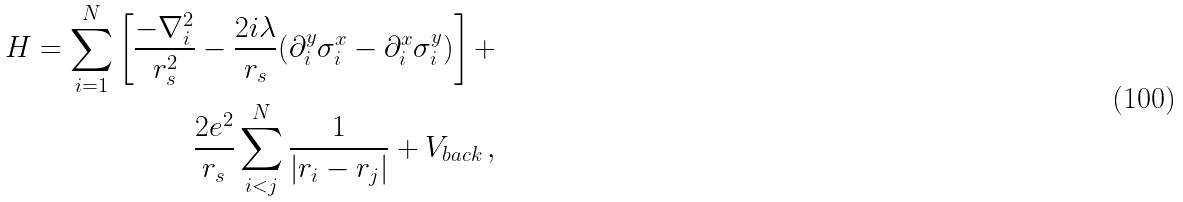<formula> <loc_0><loc_0><loc_500><loc_500>H = \sum ^ { N } _ { i = 1 } \left [ \frac { - \nabla ^ { 2 } _ { i } } { r _ { s } ^ { 2 } } - \frac { 2 i \lambda } { r _ { s } } ( \partial _ { i } ^ { y } \sigma _ { i } ^ { x } - \partial _ { i } ^ { x } \sigma _ { i } ^ { y } ) \right ] + \\ \frac { 2 e ^ { 2 } } { r _ { s } } \sum ^ { N } _ { i < j } \frac { 1 } { | r _ { i } - r _ { j } | } + V _ { b a c k } \, ,</formula> 